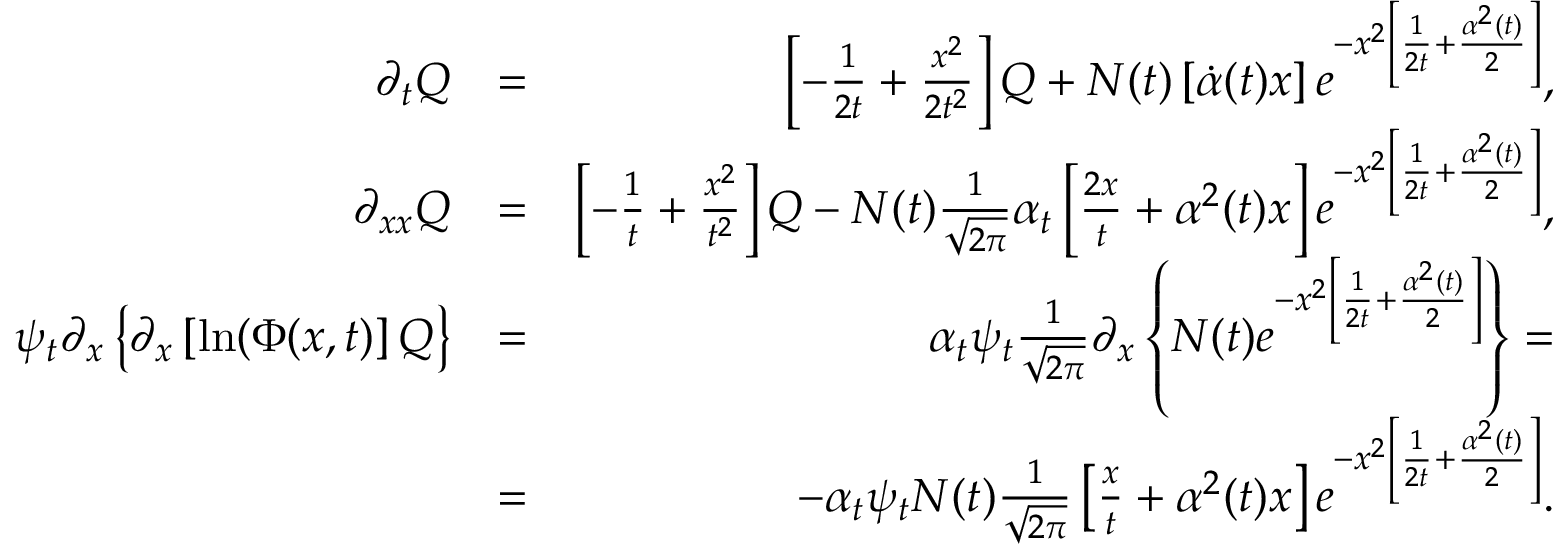Convert formula to latex. <formula><loc_0><loc_0><loc_500><loc_500>\begin{array} { r l r } { \partial _ { t } Q } & { = } & { \left [ - \frac { 1 } { 2 t } + \frac { x ^ { 2 } } { 2 t ^ { 2 } } \right ] Q + N ( t ) \left [ \dot { \alpha } ( t ) x \right ] e ^ { - x ^ { 2 } \left [ \frac { 1 } { 2 t } + \frac { \alpha ^ { 2 } ( t ) } { 2 } \right ] } , } \\ { \partial _ { x x } Q } & { = } & { \left [ - \frac { 1 } { t } + \frac { x ^ { 2 } } { t ^ { 2 } } \right ] Q - N ( t ) \frac { 1 } { \sqrt { 2 \pi } } \alpha _ { t } \left [ \frac { 2 x } { t } + \alpha ^ { 2 } ( t ) x \right ] e ^ { - x ^ { 2 } \left [ \frac { 1 } { 2 t } + \frac { \alpha ^ { 2 } ( t ) } { 2 } \right ] } , } \\ { \psi _ { t } \partial _ { x } \left \{ \partial _ { x } \left [ \ln ( \Phi ( x , t ) \right ] Q \right \} } & { = } & { \alpha _ { t } \psi _ { t } \frac { 1 } { \sqrt { 2 \pi } } \partial _ { x } \left \{ N ( t ) e ^ { - x ^ { 2 } \left [ \frac { 1 } { 2 t } + \frac { \alpha ^ { 2 } ( t ) } { 2 } \right ] } \right \} = } \\ & { = } & { - \alpha _ { t } \psi _ { t } N ( t ) \frac { 1 } { \sqrt { 2 \pi } } \left [ \frac { x } { t } + \alpha ^ { 2 } ( t ) x \right ] e ^ { - x ^ { 2 } \left [ \frac { 1 } { 2 t } + \frac { \alpha ^ { 2 } ( t ) } { 2 } \right ] } . } \end{array}</formula> 